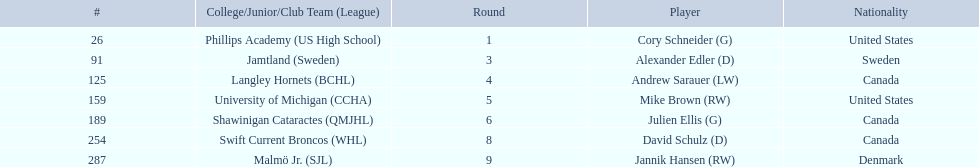What are the nationalities of the players? United States, Sweden, Canada, United States, Canada, Canada, Denmark. Of the players, which one lists his nationality as denmark? Jannik Hansen (RW). 